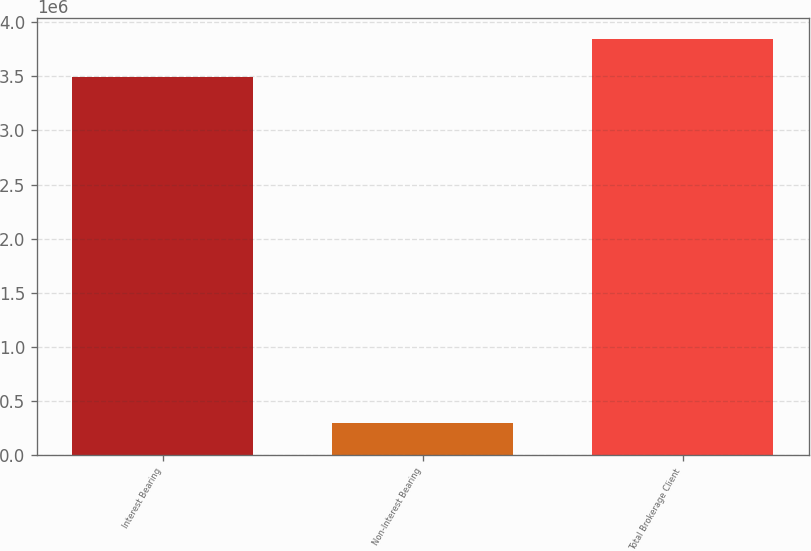<chart> <loc_0><loc_0><loc_500><loc_500><bar_chart><fcel>Interest Bearing<fcel>Non-Interest Bearing<fcel>Total Brokerage Client<nl><fcel>3.49697e+06<fcel>292896<fcel>3.84667e+06<nl></chart> 